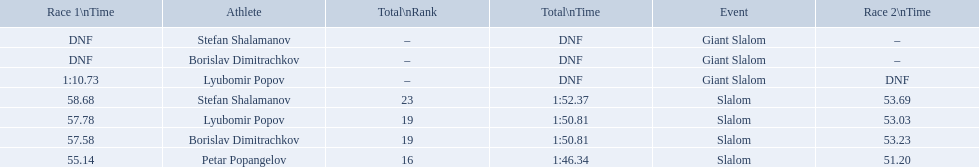What are all the competitions lyubomir popov competed in? Lyubomir Popov, Lyubomir Popov. Of those, which were giant slalom races? Giant Slalom. What was his time in race 1? 1:10.73. 